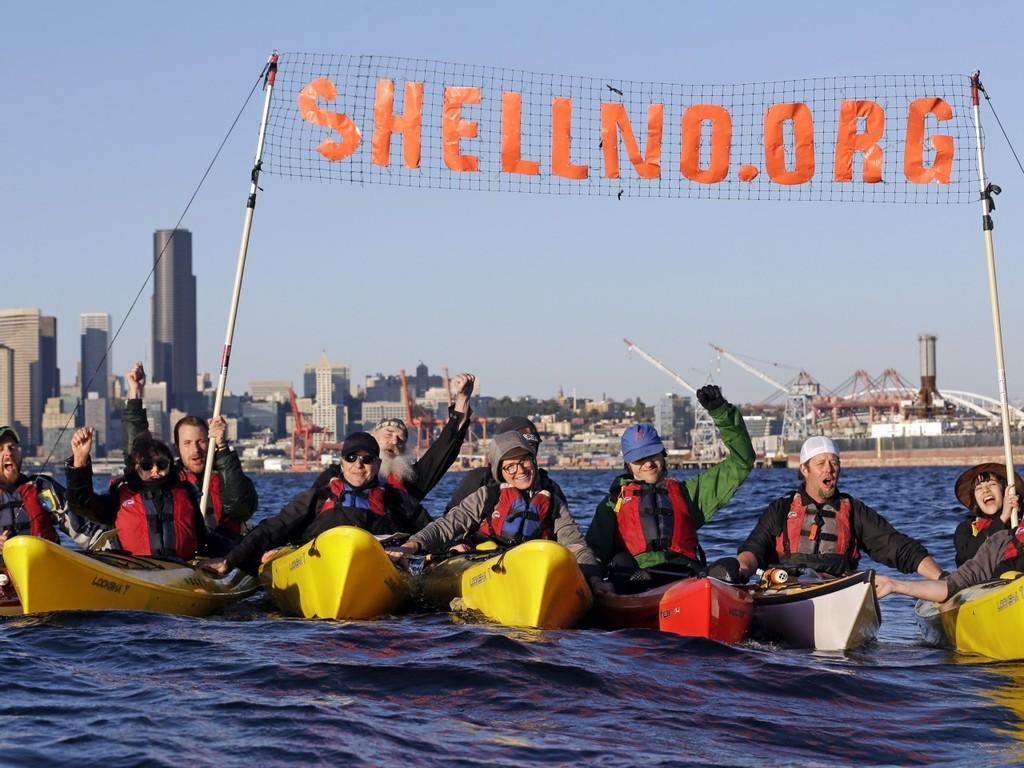Describe this image in one or two sentences. This image consists of many persons boating. They are wearing jackets and holding a banner. In the background, we can see many skyscrapers and buildings. At the bottom, there is water. 